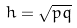Convert formula to latex. <formula><loc_0><loc_0><loc_500><loc_500>h = { \sqrt { p q } }</formula> 